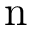Convert formula to latex. <formula><loc_0><loc_0><loc_500><loc_500>n</formula> 